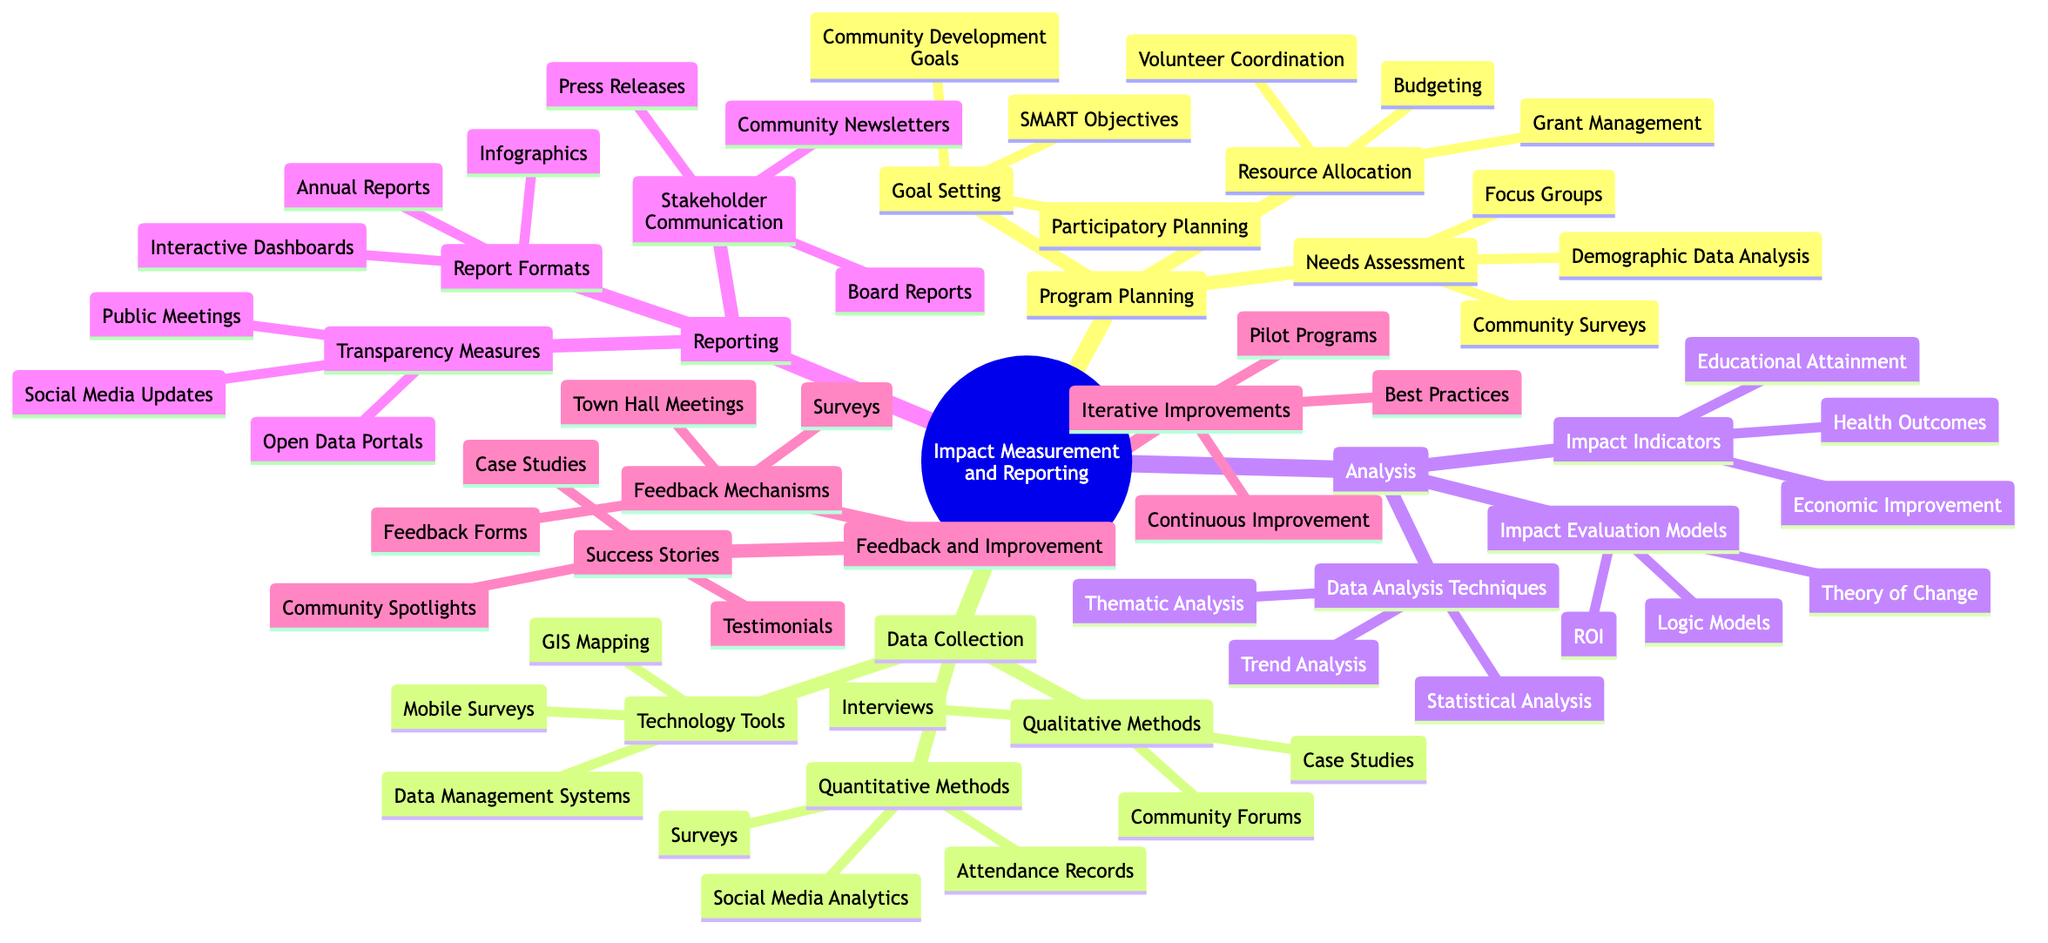What are the three aspects of Program Planning? The main branches under Program Planning are Needs Assessment, Goal Setting, and Resource Allocation. Each of these represents a key focus area in the planning phase of community programs.
Answer: Needs Assessment, Goal Setting, Resource Allocation How many types of Data Collection methods are listed? Under the Data Collection node, there are three main categories: Qualitative Methods, Quantitative Methods, and Technology Tools. Each category includes specific data collection methods.
Answer: 3 What is one example of an Impact Indicator? The Analysis section lists several Impact Indicators, one of which is Health Outcomes. This specifies a measurable aspect of program impact.
Answer: Health Outcomes What types of Report Formats are included in the Reporting section? The Reporting node details several formats, including Annual Reports, Infographics, and Interactive Dashboards. These formats are used to present findings to stakeholders.
Answer: Annual Reports, Infographics, Interactive Dashboards What do Feedback Mechanisms include? Under the Feedback and Improvement section, Feedback Mechanisms comprise Surveys, Feedback Forms, and Town Hall Meetings. These are methods used to gather community input.
Answer: Surveys, Feedback Forms, Town Hall Meetings How are the iterative improvements categorized? The Feedback and Improvement section outlines Iterative Improvements including Continuous Improvement, Pilot Programs, and Best Practices. These categories help in refining community programs over time.
Answer: Continuous Improvement, Pilot Programs, Best Practices What is one method listed under Qualitative Methods? The Data Collection section specifies that interviews are one of the methods used to qualitatively gauge community feedback and experiences.
Answer: Interviews Which Communication method is used for Stakeholder Communication? Stakeholder Communication includes Board Reports, which are formal updates provided to the governing body of an organization regarding program status and impact.
Answer: Board Reports What are the Transparency Measures mentioned? In the Reporting segment, Transparency Measures are described as Public Meetings, Open Data Portals, and Social Media Updates, which enhance accountability and openness with the community.
Answer: Public Meetings, Open Data Portals, Social Media Updates 